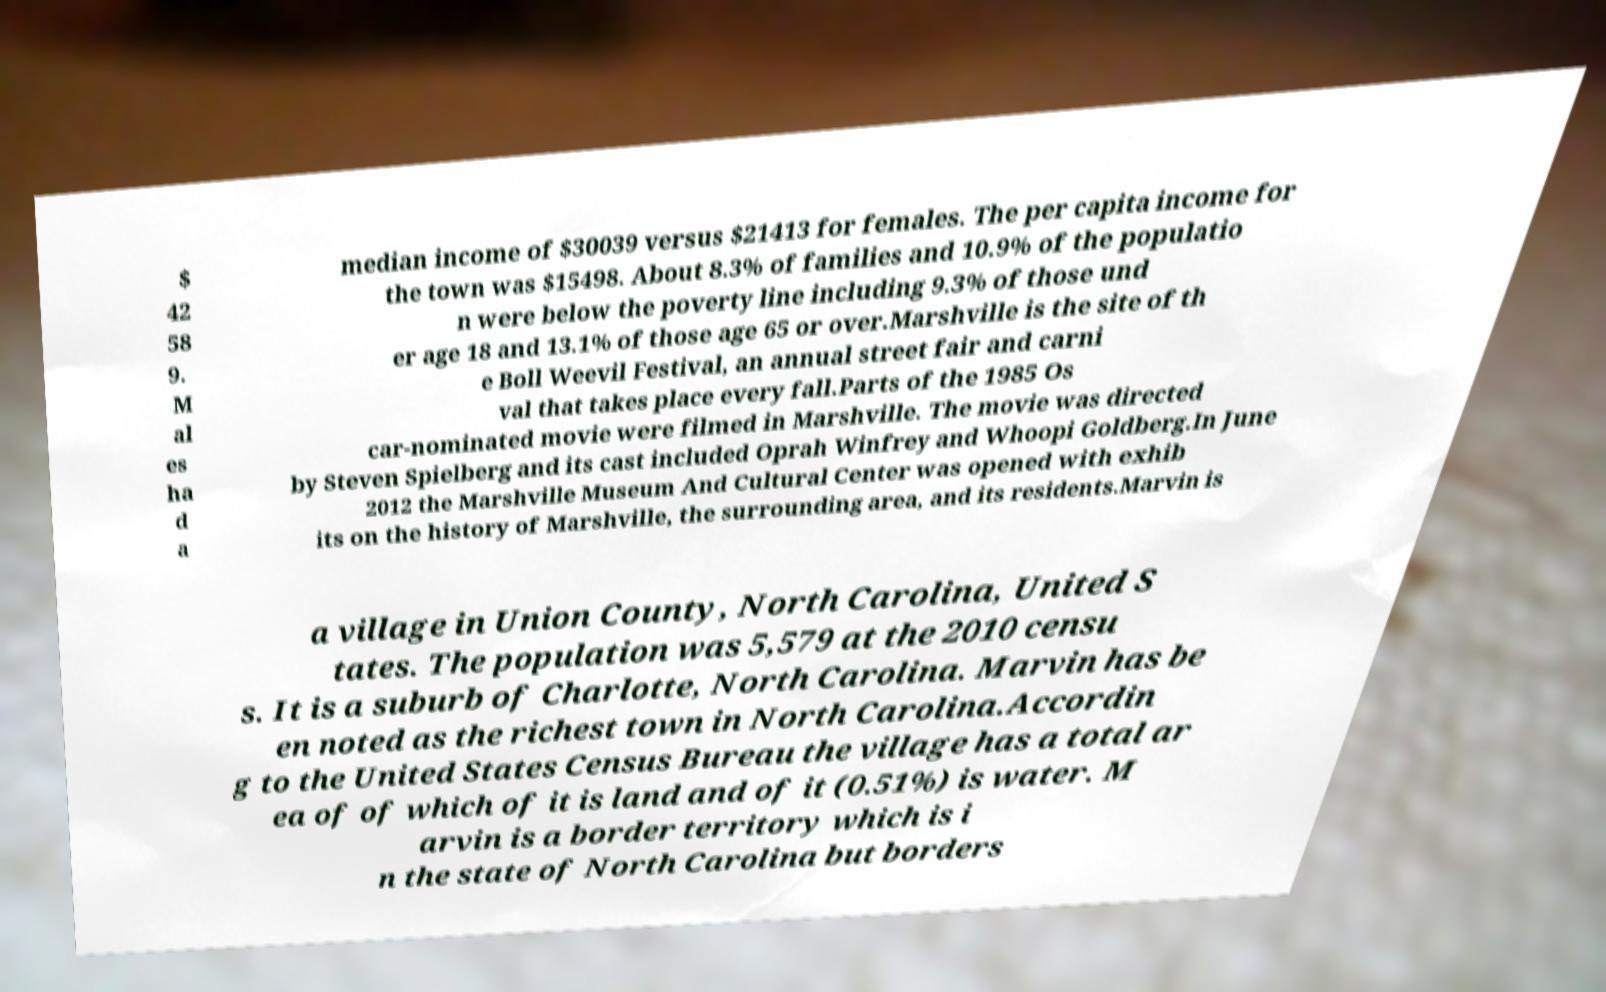Please identify and transcribe the text found in this image. $ 42 58 9. M al es ha d a median income of $30039 versus $21413 for females. The per capita income for the town was $15498. About 8.3% of families and 10.9% of the populatio n were below the poverty line including 9.3% of those und er age 18 and 13.1% of those age 65 or over.Marshville is the site of th e Boll Weevil Festival, an annual street fair and carni val that takes place every fall.Parts of the 1985 Os car-nominated movie were filmed in Marshville. The movie was directed by Steven Spielberg and its cast included Oprah Winfrey and Whoopi Goldberg.In June 2012 the Marshville Museum And Cultural Center was opened with exhib its on the history of Marshville, the surrounding area, and its residents.Marvin is a village in Union County, North Carolina, United S tates. The population was 5,579 at the 2010 censu s. It is a suburb of Charlotte, North Carolina. Marvin has be en noted as the richest town in North Carolina.Accordin g to the United States Census Bureau the village has a total ar ea of of which of it is land and of it (0.51%) is water. M arvin is a border territory which is i n the state of North Carolina but borders 